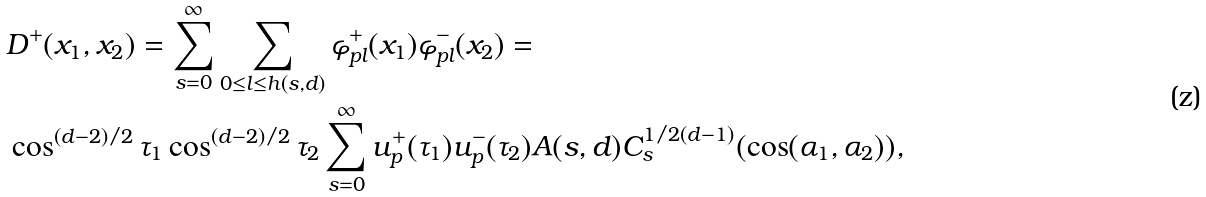<formula> <loc_0><loc_0><loc_500><loc_500>& D ^ { + } ( x _ { 1 } , x _ { 2 } ) = \sum _ { s = 0 } ^ { \infty } \sum _ { 0 \leq l \leq h ( s , d ) } \varphi ^ { + } _ { p l } ( x _ { 1 } ) \varphi ^ { - } _ { p l } ( x _ { 2 } ) = \\ & \cos ^ { ( d - 2 ) / 2 } \tau _ { 1 } \cos ^ { ( d - 2 ) / 2 } \tau _ { 2 } \sum _ { s = 0 } ^ { \infty } u ^ { + } _ { p } ( \tau _ { 1 } ) u ^ { - } _ { p } ( \tau _ { 2 } ) A ( s , d ) C ^ { 1 / 2 ( d - 1 ) } _ { s } ( \cos ( \alpha _ { 1 } , \alpha _ { 2 } ) ) ,</formula> 